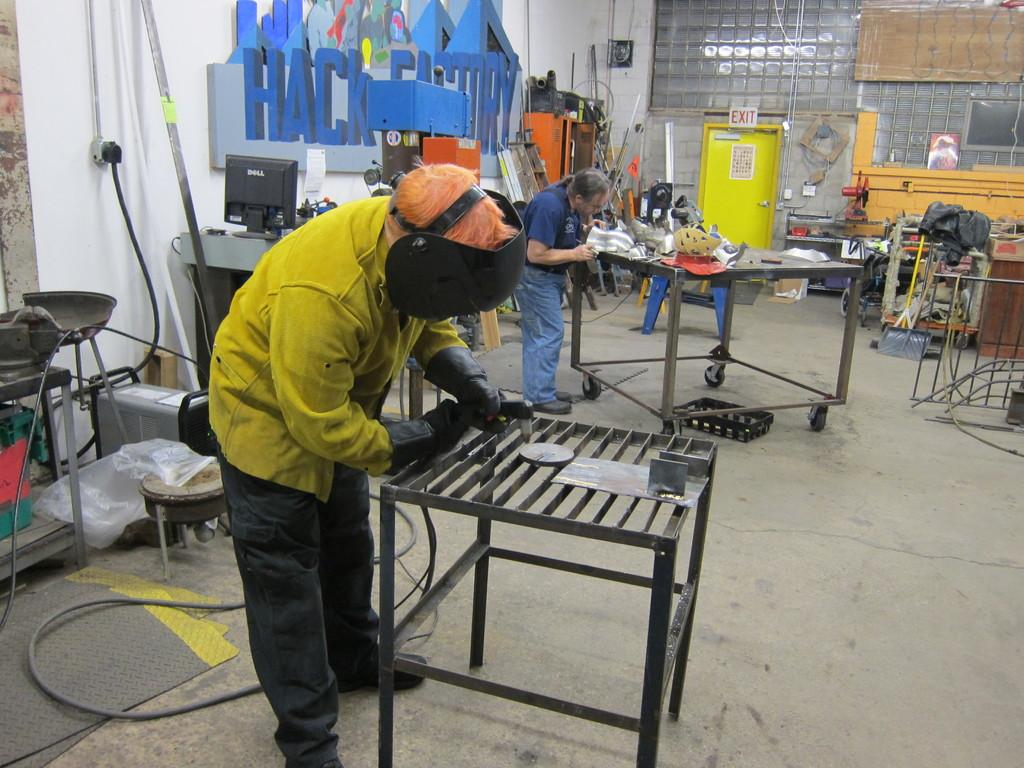How many people are in the image? There are two persons standing in the image. What is the surface they are standing on? The persons are standing on the floor. What other objects can be seen in the image? There is a table and other machines on the floor in the image. Is there any entrance or exit visible in the image? Yes, there is a door in the image. What type of flowers can be seen growing on the door in the image? There are no flowers growing on the door in the image; the door is a part of the structure and does not have any plants on it. 